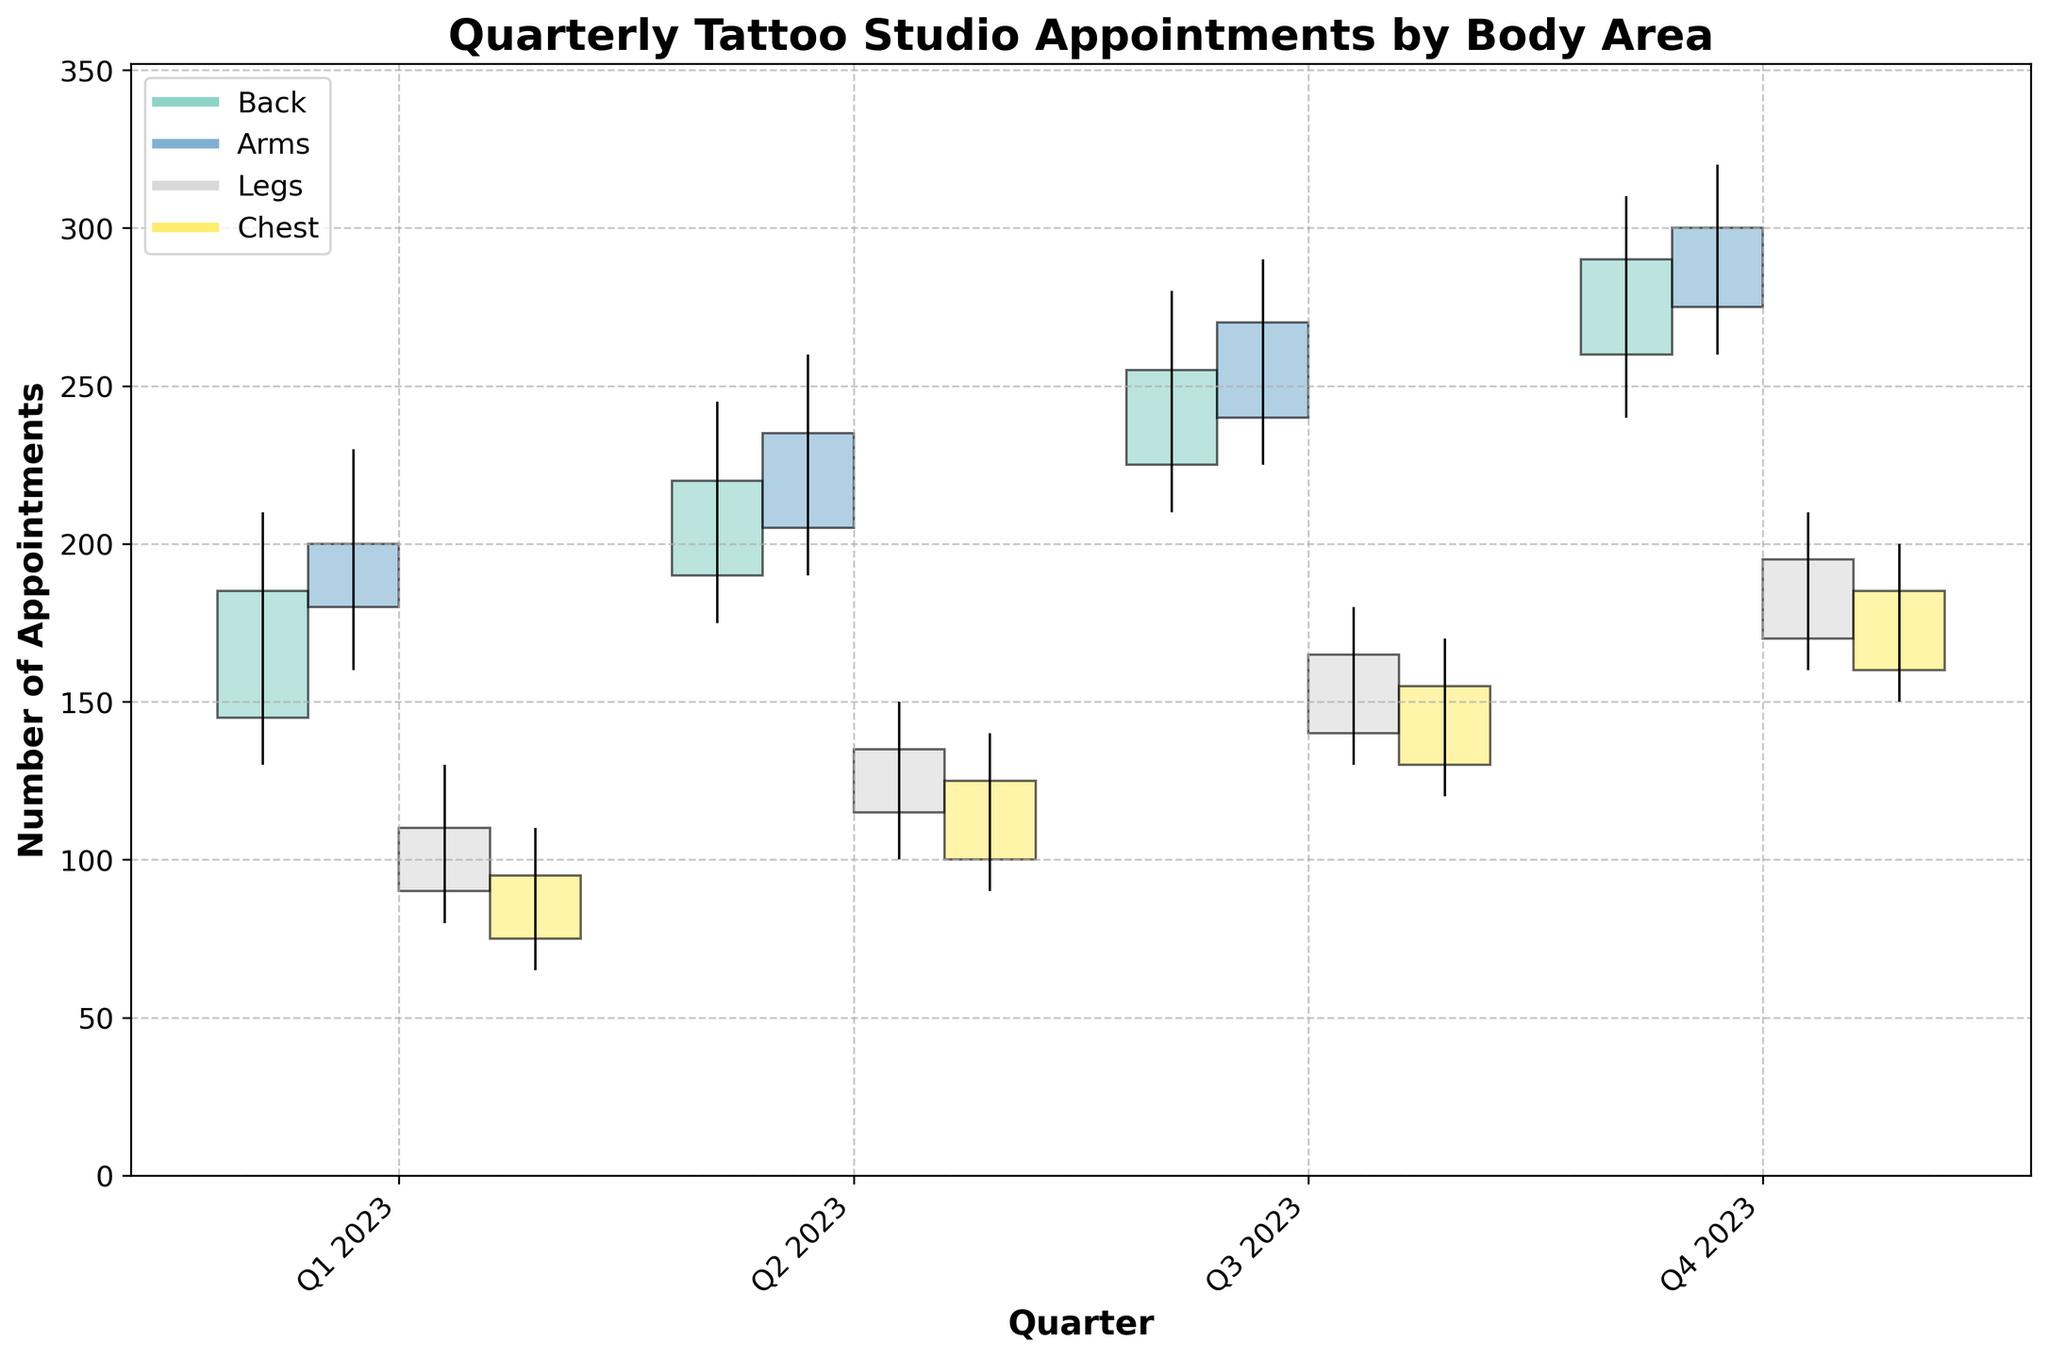What's the highest number of appointments for each body area in Q4 2023? Looking at Q4 2023, we see the highest values for each body area. These are: Back (310), Arms (320), Legs (210), Chest (200).
Answer: Back: 310, Arms: 320, Legs: 210, Chest: 200 What is the change in tattoo appointments for the Legs area from Q1 to Q4 2023? For Legs in Q1, the opening value is 90 and the closing value in Q4 is 195. The change is 195 - 90.
Answer: 105 Which body area had the highest increase in appointments from Q1 to Q2 2023? Comparing the closing values from Q1 to Q2: Back (185 to 220), Arms (200 to 235), Legs (110 to 135), Chest (95 to 125). The highest increase is for the Chest area with a change of 30 appointments.
Answer: Chest Which body area had the lowest number of appointments in Q1 2023? Checking the closing values for Q1: Back (185), Arms (200), Legs (110), Chest (95). The Chest area had the lowest with 95 appointments.
Answer: Chest What is the average high value for Arms across all quarters in 2023? Summing the high values for Arms: 230 + 260 + 290 + 320 = 1100. The average is 1100 / 4.
Answer: 275 Which quarter had the highest minimum number of appointments for the Chest area? Checking the low values for the Chest across all quarters: Q1 (65), Q2 (90), Q3 (120), Q4 (150). Q4 has the highest low value of 150.
Answer: Q4 Was there any quarter where the closing value was higher than the high value of the previous quarter for any body area? Comparing Q2 closings to Q1 highs for all body areas: Back (220 vs 210), Arms (235 vs 230), Legs (135 vs 130), Chest (125 vs 110). The pattern follows similarly in subsequent quarters. No closings were higher than the high of the previous quarters.
Answer: No Which body area showed the most consistency in appointments throughout 2023, judging by the smallest range of high and low values? Calculating range for each body area: Back (310-130=180), Arms (320-160=160), Legs (210-80=130), Chest (200-65=135). The Legs area has the smallest range.
Answer: Legs 